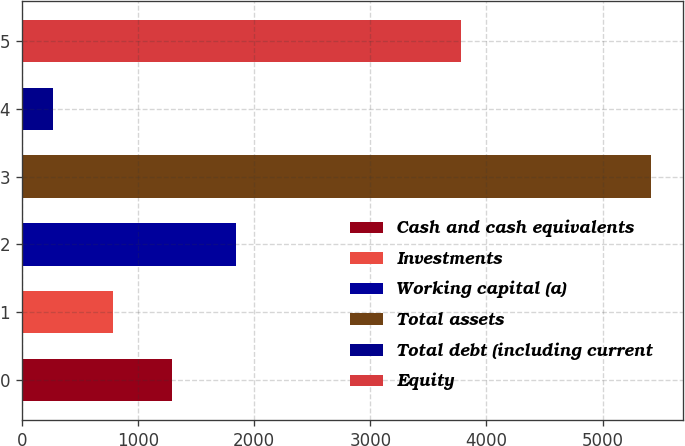<chart> <loc_0><loc_0><loc_500><loc_500><bar_chart><fcel>Cash and cash equivalents<fcel>Investments<fcel>Working capital (a)<fcel>Total assets<fcel>Total debt (including current<fcel>Equity<nl><fcel>1296.92<fcel>781.76<fcel>1841.5<fcel>5418.2<fcel>266.6<fcel>3784.6<nl></chart> 